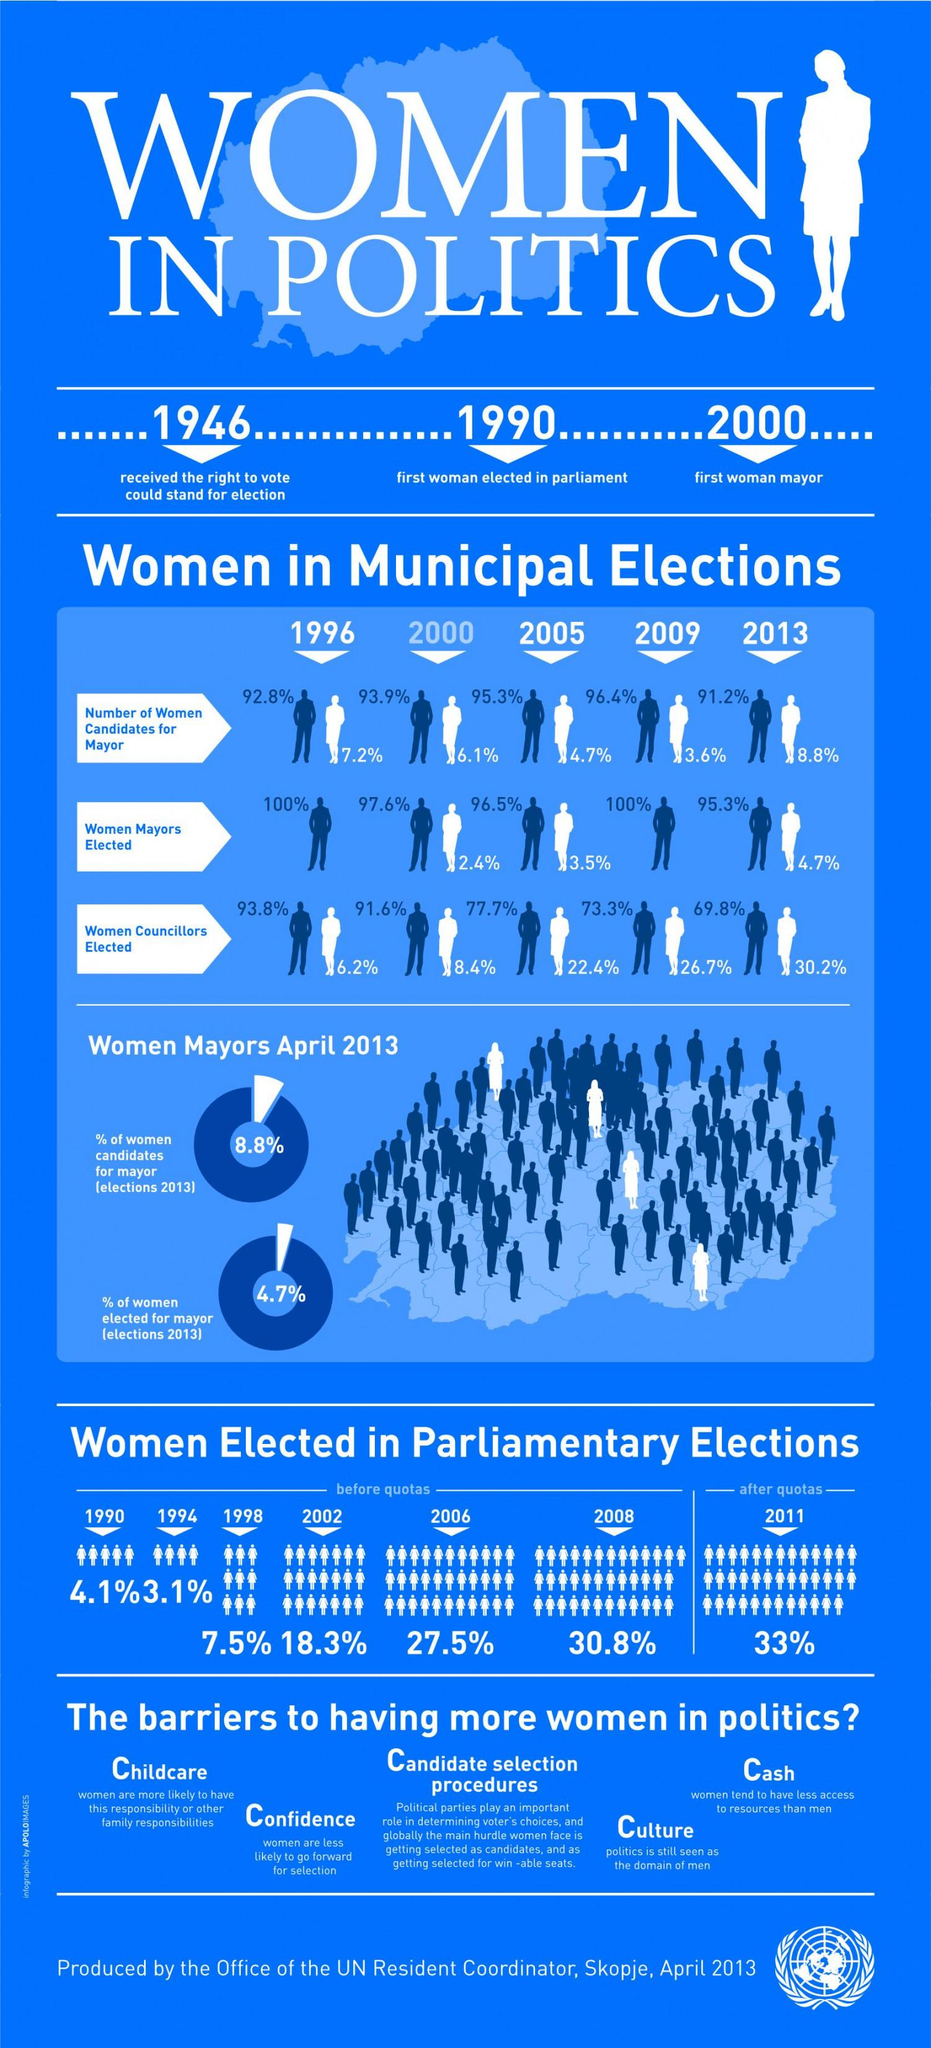Identify some key points in this picture. In the 2005 elections for mayor, a total of 4.7% of the candidates were women. According to the infographic, in 2011, there were 33% women elected in parliamentary elections. In 1990, the first woman was elected to parliament. In the year 1946, women were granted the right to vote. In 2005, only 3.5% of women were elected as mayors. 